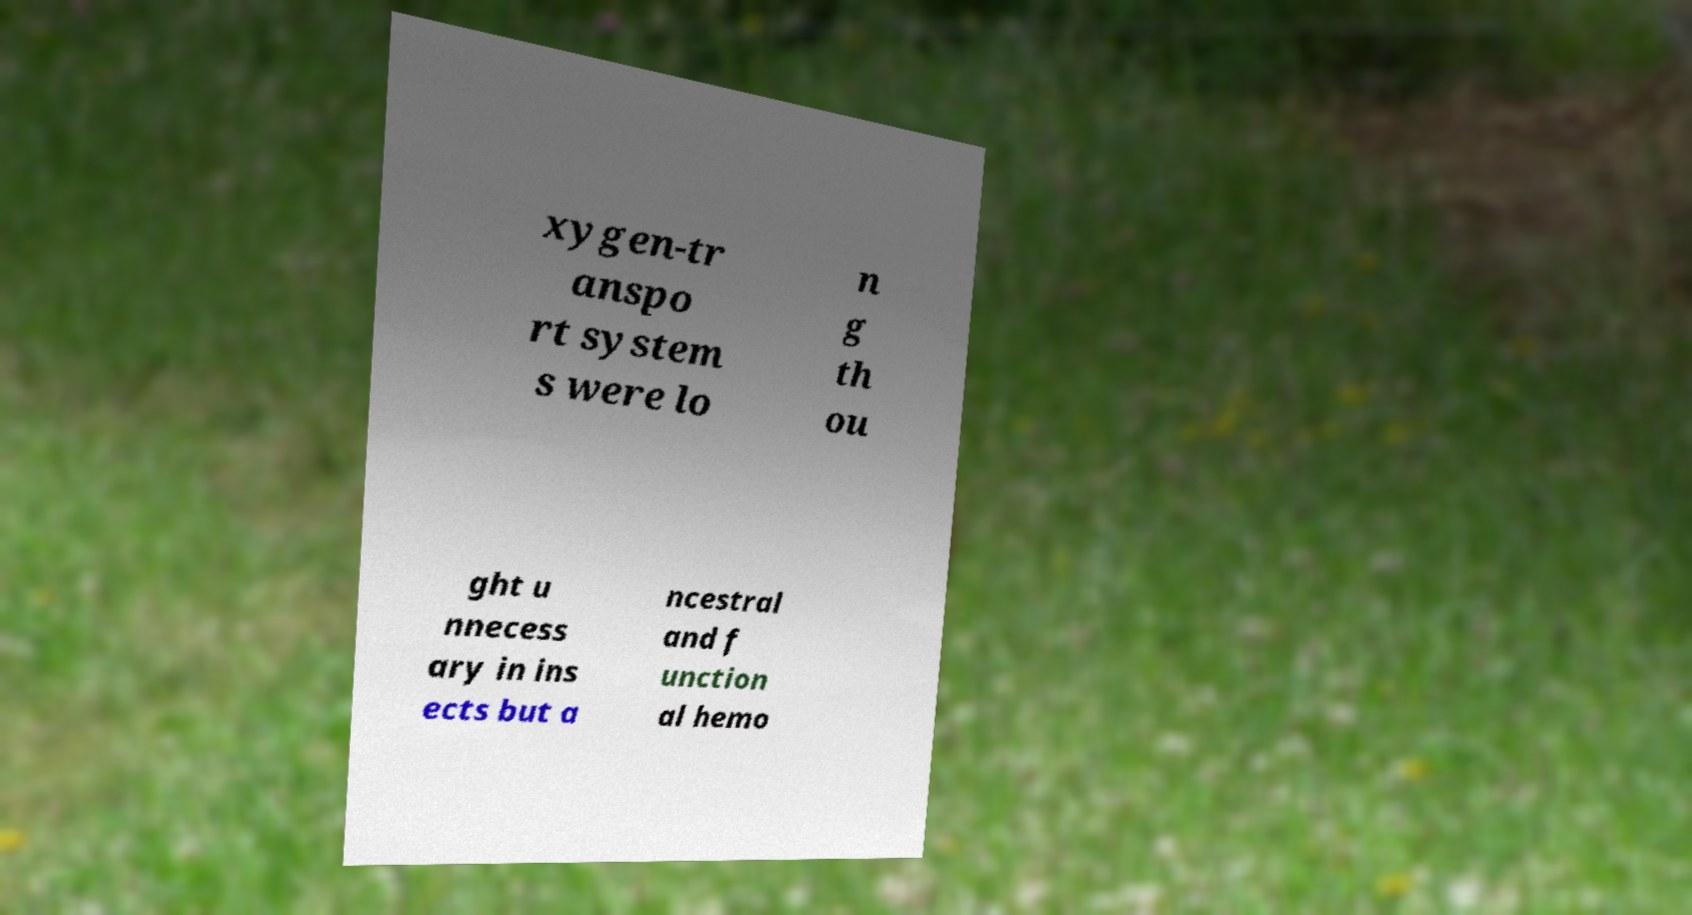What messages or text are displayed in this image? I need them in a readable, typed format. xygen-tr anspo rt system s were lo n g th ou ght u nnecess ary in ins ects but a ncestral and f unction al hemo 